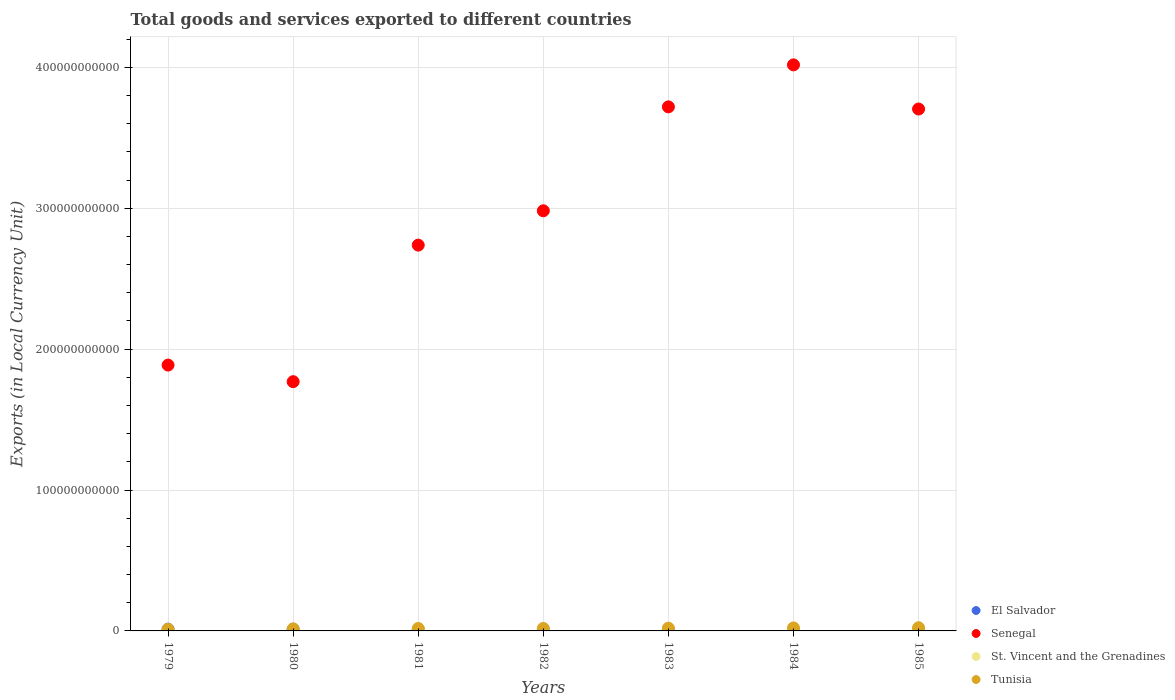How many different coloured dotlines are there?
Make the answer very short. 4. Is the number of dotlines equal to the number of legend labels?
Offer a very short reply. Yes. What is the Amount of goods and services exports in St. Vincent and the Grenadines in 1982?
Offer a very short reply. 1.36e+08. Across all years, what is the maximum Amount of goods and services exports in Tunisia?
Give a very brief answer. 2.25e+09. Across all years, what is the minimum Amount of goods and services exports in St. Vincent and the Grenadines?
Make the answer very short. 7.63e+07. In which year was the Amount of goods and services exports in El Salvador maximum?
Offer a terse response. 1979. In which year was the Amount of goods and services exports in St. Vincent and the Grenadines minimum?
Provide a short and direct response. 1979. What is the total Amount of goods and services exports in Senegal in the graph?
Make the answer very short. 2.08e+12. What is the difference between the Amount of goods and services exports in Senegal in 1982 and that in 1984?
Keep it short and to the point. -1.04e+11. What is the difference between the Amount of goods and services exports in El Salvador in 1983 and the Amount of goods and services exports in Tunisia in 1980?
Make the answer very short. -5.66e+08. What is the average Amount of goods and services exports in El Salvador per year?
Provide a short and direct response. 9.57e+08. In the year 1980, what is the difference between the Amount of goods and services exports in El Salvador and Amount of goods and services exports in St. Vincent and the Grenadines?
Ensure brevity in your answer.  1.13e+09. What is the ratio of the Amount of goods and services exports in St. Vincent and the Grenadines in 1981 to that in 1985?
Keep it short and to the point. 0.52. What is the difference between the highest and the second highest Amount of goods and services exports in El Salvador?
Your answer should be compact. 5.96e+07. What is the difference between the highest and the lowest Amount of goods and services exports in Tunisia?
Offer a terse response. 1.11e+09. In how many years, is the Amount of goods and services exports in Senegal greater than the average Amount of goods and services exports in Senegal taken over all years?
Keep it short and to the point. 4. Is it the case that in every year, the sum of the Amount of goods and services exports in El Salvador and Amount of goods and services exports in St. Vincent and the Grenadines  is greater than the sum of Amount of goods and services exports in Tunisia and Amount of goods and services exports in Senegal?
Provide a short and direct response. Yes. Does the Amount of goods and services exports in El Salvador monotonically increase over the years?
Your answer should be very brief. No. Is the Amount of goods and services exports in El Salvador strictly less than the Amount of goods and services exports in Tunisia over the years?
Give a very brief answer. No. How many years are there in the graph?
Provide a succinct answer. 7. What is the difference between two consecutive major ticks on the Y-axis?
Ensure brevity in your answer.  1.00e+11. Are the values on the major ticks of Y-axis written in scientific E-notation?
Your answer should be compact. No. Does the graph contain any zero values?
Provide a succinct answer. No. Does the graph contain grids?
Your answer should be compact. Yes. Where does the legend appear in the graph?
Provide a short and direct response. Bottom right. How many legend labels are there?
Give a very brief answer. 4. What is the title of the graph?
Offer a terse response. Total goods and services exported to different countries. What is the label or title of the X-axis?
Ensure brevity in your answer.  Years. What is the label or title of the Y-axis?
Your answer should be compact. Exports (in Local Currency Unit). What is the Exports (in Local Currency Unit) of El Salvador in 1979?
Your answer should be compact. 1.28e+09. What is the Exports (in Local Currency Unit) in Senegal in 1979?
Provide a succinct answer. 1.89e+11. What is the Exports (in Local Currency Unit) of St. Vincent and the Grenadines in 1979?
Keep it short and to the point. 7.63e+07. What is the Exports (in Local Currency Unit) in Tunisia in 1979?
Offer a terse response. 1.14e+09. What is the Exports (in Local Currency Unit) of El Salvador in 1980?
Your answer should be compact. 1.22e+09. What is the Exports (in Local Currency Unit) in Senegal in 1980?
Offer a terse response. 1.77e+11. What is the Exports (in Local Currency Unit) of St. Vincent and the Grenadines in 1980?
Keep it short and to the point. 8.95e+07. What is the Exports (in Local Currency Unit) of Tunisia in 1980?
Offer a very short reply. 1.42e+09. What is the Exports (in Local Currency Unit) of El Salvador in 1981?
Your answer should be compact. 9.17e+08. What is the Exports (in Local Currency Unit) in Senegal in 1981?
Give a very brief answer. 2.74e+11. What is the Exports (in Local Currency Unit) of St. Vincent and the Grenadines in 1981?
Provide a succinct answer. 1.16e+08. What is the Exports (in Local Currency Unit) of Tunisia in 1981?
Make the answer very short. 1.72e+09. What is the Exports (in Local Currency Unit) in El Salvador in 1982?
Make the answer very short. 7.74e+08. What is the Exports (in Local Currency Unit) in Senegal in 1982?
Provide a short and direct response. 2.98e+11. What is the Exports (in Local Currency Unit) in St. Vincent and the Grenadines in 1982?
Offer a very short reply. 1.36e+08. What is the Exports (in Local Currency Unit) of Tunisia in 1982?
Make the answer very short. 1.77e+09. What is the Exports (in Local Currency Unit) of El Salvador in 1983?
Make the answer very short. 8.59e+08. What is the Exports (in Local Currency Unit) in Senegal in 1983?
Make the answer very short. 3.72e+11. What is the Exports (in Local Currency Unit) in St. Vincent and the Grenadines in 1983?
Offer a terse response. 1.56e+08. What is the Exports (in Local Currency Unit) of Tunisia in 1983?
Keep it short and to the point. 1.95e+09. What is the Exports (in Local Currency Unit) in El Salvador in 1984?
Your answer should be very brief. 7.97e+08. What is the Exports (in Local Currency Unit) in Senegal in 1984?
Your answer should be very brief. 4.02e+11. What is the Exports (in Local Currency Unit) of St. Vincent and the Grenadines in 1984?
Provide a short and direct response. 1.93e+08. What is the Exports (in Local Currency Unit) of Tunisia in 1984?
Give a very brief answer. 2.11e+09. What is the Exports (in Local Currency Unit) in El Salvador in 1985?
Give a very brief answer. 8.48e+08. What is the Exports (in Local Currency Unit) of Senegal in 1985?
Keep it short and to the point. 3.70e+11. What is the Exports (in Local Currency Unit) in St. Vincent and the Grenadines in 1985?
Keep it short and to the point. 2.22e+08. What is the Exports (in Local Currency Unit) of Tunisia in 1985?
Keep it short and to the point. 2.25e+09. Across all years, what is the maximum Exports (in Local Currency Unit) in El Salvador?
Your response must be concise. 1.28e+09. Across all years, what is the maximum Exports (in Local Currency Unit) in Senegal?
Your answer should be compact. 4.02e+11. Across all years, what is the maximum Exports (in Local Currency Unit) of St. Vincent and the Grenadines?
Your answer should be compact. 2.22e+08. Across all years, what is the maximum Exports (in Local Currency Unit) of Tunisia?
Provide a succinct answer. 2.25e+09. Across all years, what is the minimum Exports (in Local Currency Unit) of El Salvador?
Offer a very short reply. 7.74e+08. Across all years, what is the minimum Exports (in Local Currency Unit) in Senegal?
Provide a short and direct response. 1.77e+11. Across all years, what is the minimum Exports (in Local Currency Unit) in St. Vincent and the Grenadines?
Provide a short and direct response. 7.63e+07. Across all years, what is the minimum Exports (in Local Currency Unit) of Tunisia?
Offer a terse response. 1.14e+09. What is the total Exports (in Local Currency Unit) in El Salvador in the graph?
Ensure brevity in your answer.  6.70e+09. What is the total Exports (in Local Currency Unit) in Senegal in the graph?
Your answer should be very brief. 2.08e+12. What is the total Exports (in Local Currency Unit) in St. Vincent and the Grenadines in the graph?
Your response must be concise. 9.89e+08. What is the total Exports (in Local Currency Unit) in Tunisia in the graph?
Provide a succinct answer. 1.24e+1. What is the difference between the Exports (in Local Currency Unit) in El Salvador in 1979 and that in 1980?
Ensure brevity in your answer.  5.96e+07. What is the difference between the Exports (in Local Currency Unit) in Senegal in 1979 and that in 1980?
Provide a succinct answer. 1.18e+1. What is the difference between the Exports (in Local Currency Unit) of St. Vincent and the Grenadines in 1979 and that in 1980?
Your answer should be very brief. -1.32e+07. What is the difference between the Exports (in Local Currency Unit) in Tunisia in 1979 and that in 1980?
Provide a succinct answer. -2.86e+08. What is the difference between the Exports (in Local Currency Unit) in El Salvador in 1979 and that in 1981?
Ensure brevity in your answer.  3.64e+08. What is the difference between the Exports (in Local Currency Unit) in Senegal in 1979 and that in 1981?
Keep it short and to the point. -8.51e+1. What is the difference between the Exports (in Local Currency Unit) of St. Vincent and the Grenadines in 1979 and that in 1981?
Keep it short and to the point. -3.97e+07. What is the difference between the Exports (in Local Currency Unit) of Tunisia in 1979 and that in 1981?
Keep it short and to the point. -5.83e+08. What is the difference between the Exports (in Local Currency Unit) in El Salvador in 1979 and that in 1982?
Provide a succinct answer. 5.06e+08. What is the difference between the Exports (in Local Currency Unit) of Senegal in 1979 and that in 1982?
Keep it short and to the point. -1.10e+11. What is the difference between the Exports (in Local Currency Unit) in St. Vincent and the Grenadines in 1979 and that in 1982?
Ensure brevity in your answer.  -5.96e+07. What is the difference between the Exports (in Local Currency Unit) in Tunisia in 1979 and that in 1982?
Ensure brevity in your answer.  -6.34e+08. What is the difference between the Exports (in Local Currency Unit) in El Salvador in 1979 and that in 1983?
Your answer should be very brief. 4.22e+08. What is the difference between the Exports (in Local Currency Unit) in Senegal in 1979 and that in 1983?
Your response must be concise. -1.83e+11. What is the difference between the Exports (in Local Currency Unit) of St. Vincent and the Grenadines in 1979 and that in 1983?
Offer a very short reply. -7.94e+07. What is the difference between the Exports (in Local Currency Unit) of Tunisia in 1979 and that in 1983?
Your response must be concise. -8.09e+08. What is the difference between the Exports (in Local Currency Unit) of El Salvador in 1979 and that in 1984?
Your answer should be very brief. 4.84e+08. What is the difference between the Exports (in Local Currency Unit) in Senegal in 1979 and that in 1984?
Give a very brief answer. -2.13e+11. What is the difference between the Exports (in Local Currency Unit) of St. Vincent and the Grenadines in 1979 and that in 1984?
Your answer should be compact. -1.17e+08. What is the difference between the Exports (in Local Currency Unit) in Tunisia in 1979 and that in 1984?
Ensure brevity in your answer.  -9.75e+08. What is the difference between the Exports (in Local Currency Unit) in El Salvador in 1979 and that in 1985?
Your answer should be compact. 4.32e+08. What is the difference between the Exports (in Local Currency Unit) in Senegal in 1979 and that in 1985?
Your answer should be very brief. -1.82e+11. What is the difference between the Exports (in Local Currency Unit) of St. Vincent and the Grenadines in 1979 and that in 1985?
Your answer should be very brief. -1.46e+08. What is the difference between the Exports (in Local Currency Unit) in Tunisia in 1979 and that in 1985?
Offer a terse response. -1.11e+09. What is the difference between the Exports (in Local Currency Unit) in El Salvador in 1980 and that in 1981?
Make the answer very short. 3.04e+08. What is the difference between the Exports (in Local Currency Unit) of Senegal in 1980 and that in 1981?
Offer a very short reply. -9.69e+1. What is the difference between the Exports (in Local Currency Unit) in St. Vincent and the Grenadines in 1980 and that in 1981?
Keep it short and to the point. -2.65e+07. What is the difference between the Exports (in Local Currency Unit) in Tunisia in 1980 and that in 1981?
Give a very brief answer. -2.97e+08. What is the difference between the Exports (in Local Currency Unit) of El Salvador in 1980 and that in 1982?
Keep it short and to the point. 4.47e+08. What is the difference between the Exports (in Local Currency Unit) in Senegal in 1980 and that in 1982?
Offer a very short reply. -1.21e+11. What is the difference between the Exports (in Local Currency Unit) of St. Vincent and the Grenadines in 1980 and that in 1982?
Make the answer very short. -4.65e+07. What is the difference between the Exports (in Local Currency Unit) of Tunisia in 1980 and that in 1982?
Give a very brief answer. -3.49e+08. What is the difference between the Exports (in Local Currency Unit) in El Salvador in 1980 and that in 1983?
Offer a terse response. 3.62e+08. What is the difference between the Exports (in Local Currency Unit) in Senegal in 1980 and that in 1983?
Keep it short and to the point. -1.95e+11. What is the difference between the Exports (in Local Currency Unit) of St. Vincent and the Grenadines in 1980 and that in 1983?
Ensure brevity in your answer.  -6.63e+07. What is the difference between the Exports (in Local Currency Unit) in Tunisia in 1980 and that in 1983?
Make the answer very short. -5.23e+08. What is the difference between the Exports (in Local Currency Unit) in El Salvador in 1980 and that in 1984?
Give a very brief answer. 4.24e+08. What is the difference between the Exports (in Local Currency Unit) of Senegal in 1980 and that in 1984?
Keep it short and to the point. -2.25e+11. What is the difference between the Exports (in Local Currency Unit) of St. Vincent and the Grenadines in 1980 and that in 1984?
Your response must be concise. -1.03e+08. What is the difference between the Exports (in Local Currency Unit) of Tunisia in 1980 and that in 1984?
Make the answer very short. -6.89e+08. What is the difference between the Exports (in Local Currency Unit) in El Salvador in 1980 and that in 1985?
Keep it short and to the point. 3.73e+08. What is the difference between the Exports (in Local Currency Unit) in Senegal in 1980 and that in 1985?
Keep it short and to the point. -1.94e+11. What is the difference between the Exports (in Local Currency Unit) of St. Vincent and the Grenadines in 1980 and that in 1985?
Offer a very short reply. -1.33e+08. What is the difference between the Exports (in Local Currency Unit) in Tunisia in 1980 and that in 1985?
Offer a terse response. -8.28e+08. What is the difference between the Exports (in Local Currency Unit) in El Salvador in 1981 and that in 1982?
Provide a succinct answer. 1.43e+08. What is the difference between the Exports (in Local Currency Unit) in Senegal in 1981 and that in 1982?
Your answer should be compact. -2.44e+1. What is the difference between the Exports (in Local Currency Unit) of St. Vincent and the Grenadines in 1981 and that in 1982?
Provide a short and direct response. -2.00e+07. What is the difference between the Exports (in Local Currency Unit) of Tunisia in 1981 and that in 1982?
Provide a short and direct response. -5.14e+07. What is the difference between the Exports (in Local Currency Unit) of El Salvador in 1981 and that in 1983?
Give a very brief answer. 5.83e+07. What is the difference between the Exports (in Local Currency Unit) in Senegal in 1981 and that in 1983?
Ensure brevity in your answer.  -9.81e+1. What is the difference between the Exports (in Local Currency Unit) in St. Vincent and the Grenadines in 1981 and that in 1983?
Offer a very short reply. -3.98e+07. What is the difference between the Exports (in Local Currency Unit) of Tunisia in 1981 and that in 1983?
Keep it short and to the point. -2.26e+08. What is the difference between the Exports (in Local Currency Unit) in El Salvador in 1981 and that in 1984?
Give a very brief answer. 1.20e+08. What is the difference between the Exports (in Local Currency Unit) in Senegal in 1981 and that in 1984?
Provide a succinct answer. -1.28e+11. What is the difference between the Exports (in Local Currency Unit) in St. Vincent and the Grenadines in 1981 and that in 1984?
Offer a very short reply. -7.70e+07. What is the difference between the Exports (in Local Currency Unit) in Tunisia in 1981 and that in 1984?
Offer a terse response. -3.92e+08. What is the difference between the Exports (in Local Currency Unit) of El Salvador in 1981 and that in 1985?
Offer a very short reply. 6.86e+07. What is the difference between the Exports (in Local Currency Unit) in Senegal in 1981 and that in 1985?
Offer a terse response. -9.66e+1. What is the difference between the Exports (in Local Currency Unit) of St. Vincent and the Grenadines in 1981 and that in 1985?
Offer a terse response. -1.06e+08. What is the difference between the Exports (in Local Currency Unit) in Tunisia in 1981 and that in 1985?
Your answer should be very brief. -5.31e+08. What is the difference between the Exports (in Local Currency Unit) of El Salvador in 1982 and that in 1983?
Ensure brevity in your answer.  -8.44e+07. What is the difference between the Exports (in Local Currency Unit) of Senegal in 1982 and that in 1983?
Provide a short and direct response. -7.38e+1. What is the difference between the Exports (in Local Currency Unit) of St. Vincent and the Grenadines in 1982 and that in 1983?
Your answer should be very brief. -1.98e+07. What is the difference between the Exports (in Local Currency Unit) of Tunisia in 1982 and that in 1983?
Make the answer very short. -1.74e+08. What is the difference between the Exports (in Local Currency Unit) of El Salvador in 1982 and that in 1984?
Make the answer very short. -2.23e+07. What is the difference between the Exports (in Local Currency Unit) of Senegal in 1982 and that in 1984?
Make the answer very short. -1.04e+11. What is the difference between the Exports (in Local Currency Unit) of St. Vincent and the Grenadines in 1982 and that in 1984?
Give a very brief answer. -5.70e+07. What is the difference between the Exports (in Local Currency Unit) in Tunisia in 1982 and that in 1984?
Offer a terse response. -3.40e+08. What is the difference between the Exports (in Local Currency Unit) of El Salvador in 1982 and that in 1985?
Offer a terse response. -7.41e+07. What is the difference between the Exports (in Local Currency Unit) in Senegal in 1982 and that in 1985?
Offer a terse response. -7.22e+1. What is the difference between the Exports (in Local Currency Unit) in St. Vincent and the Grenadines in 1982 and that in 1985?
Your answer should be compact. -8.66e+07. What is the difference between the Exports (in Local Currency Unit) in Tunisia in 1982 and that in 1985?
Provide a short and direct response. -4.80e+08. What is the difference between the Exports (in Local Currency Unit) of El Salvador in 1983 and that in 1984?
Your answer should be very brief. 6.21e+07. What is the difference between the Exports (in Local Currency Unit) of Senegal in 1983 and that in 1984?
Provide a short and direct response. -2.98e+1. What is the difference between the Exports (in Local Currency Unit) of St. Vincent and the Grenadines in 1983 and that in 1984?
Your answer should be compact. -3.72e+07. What is the difference between the Exports (in Local Currency Unit) in Tunisia in 1983 and that in 1984?
Give a very brief answer. -1.66e+08. What is the difference between the Exports (in Local Currency Unit) in El Salvador in 1983 and that in 1985?
Your answer should be very brief. 1.03e+07. What is the difference between the Exports (in Local Currency Unit) in Senegal in 1983 and that in 1985?
Make the answer very short. 1.54e+09. What is the difference between the Exports (in Local Currency Unit) of St. Vincent and the Grenadines in 1983 and that in 1985?
Provide a succinct answer. -6.67e+07. What is the difference between the Exports (in Local Currency Unit) in Tunisia in 1983 and that in 1985?
Provide a succinct answer. -3.05e+08. What is the difference between the Exports (in Local Currency Unit) in El Salvador in 1984 and that in 1985?
Make the answer very short. -5.18e+07. What is the difference between the Exports (in Local Currency Unit) in Senegal in 1984 and that in 1985?
Offer a terse response. 3.13e+1. What is the difference between the Exports (in Local Currency Unit) in St. Vincent and the Grenadines in 1984 and that in 1985?
Your response must be concise. -2.95e+07. What is the difference between the Exports (in Local Currency Unit) of Tunisia in 1984 and that in 1985?
Offer a very short reply. -1.39e+08. What is the difference between the Exports (in Local Currency Unit) of El Salvador in 1979 and the Exports (in Local Currency Unit) of Senegal in 1980?
Provide a succinct answer. -1.76e+11. What is the difference between the Exports (in Local Currency Unit) of El Salvador in 1979 and the Exports (in Local Currency Unit) of St. Vincent and the Grenadines in 1980?
Ensure brevity in your answer.  1.19e+09. What is the difference between the Exports (in Local Currency Unit) in El Salvador in 1979 and the Exports (in Local Currency Unit) in Tunisia in 1980?
Ensure brevity in your answer.  -1.44e+08. What is the difference between the Exports (in Local Currency Unit) in Senegal in 1979 and the Exports (in Local Currency Unit) in St. Vincent and the Grenadines in 1980?
Your answer should be very brief. 1.89e+11. What is the difference between the Exports (in Local Currency Unit) of Senegal in 1979 and the Exports (in Local Currency Unit) of Tunisia in 1980?
Your answer should be very brief. 1.87e+11. What is the difference between the Exports (in Local Currency Unit) in St. Vincent and the Grenadines in 1979 and the Exports (in Local Currency Unit) in Tunisia in 1980?
Your response must be concise. -1.35e+09. What is the difference between the Exports (in Local Currency Unit) in El Salvador in 1979 and the Exports (in Local Currency Unit) in Senegal in 1981?
Your response must be concise. -2.73e+11. What is the difference between the Exports (in Local Currency Unit) in El Salvador in 1979 and the Exports (in Local Currency Unit) in St. Vincent and the Grenadines in 1981?
Keep it short and to the point. 1.16e+09. What is the difference between the Exports (in Local Currency Unit) in El Salvador in 1979 and the Exports (in Local Currency Unit) in Tunisia in 1981?
Give a very brief answer. -4.41e+08. What is the difference between the Exports (in Local Currency Unit) of Senegal in 1979 and the Exports (in Local Currency Unit) of St. Vincent and the Grenadines in 1981?
Give a very brief answer. 1.89e+11. What is the difference between the Exports (in Local Currency Unit) in Senegal in 1979 and the Exports (in Local Currency Unit) in Tunisia in 1981?
Your answer should be compact. 1.87e+11. What is the difference between the Exports (in Local Currency Unit) of St. Vincent and the Grenadines in 1979 and the Exports (in Local Currency Unit) of Tunisia in 1981?
Your answer should be compact. -1.65e+09. What is the difference between the Exports (in Local Currency Unit) in El Salvador in 1979 and the Exports (in Local Currency Unit) in Senegal in 1982?
Your answer should be very brief. -2.97e+11. What is the difference between the Exports (in Local Currency Unit) in El Salvador in 1979 and the Exports (in Local Currency Unit) in St. Vincent and the Grenadines in 1982?
Provide a succinct answer. 1.14e+09. What is the difference between the Exports (in Local Currency Unit) of El Salvador in 1979 and the Exports (in Local Currency Unit) of Tunisia in 1982?
Offer a terse response. -4.93e+08. What is the difference between the Exports (in Local Currency Unit) of Senegal in 1979 and the Exports (in Local Currency Unit) of St. Vincent and the Grenadines in 1982?
Your answer should be very brief. 1.89e+11. What is the difference between the Exports (in Local Currency Unit) of Senegal in 1979 and the Exports (in Local Currency Unit) of Tunisia in 1982?
Your response must be concise. 1.87e+11. What is the difference between the Exports (in Local Currency Unit) of St. Vincent and the Grenadines in 1979 and the Exports (in Local Currency Unit) of Tunisia in 1982?
Provide a short and direct response. -1.70e+09. What is the difference between the Exports (in Local Currency Unit) of El Salvador in 1979 and the Exports (in Local Currency Unit) of Senegal in 1983?
Ensure brevity in your answer.  -3.71e+11. What is the difference between the Exports (in Local Currency Unit) of El Salvador in 1979 and the Exports (in Local Currency Unit) of St. Vincent and the Grenadines in 1983?
Give a very brief answer. 1.12e+09. What is the difference between the Exports (in Local Currency Unit) in El Salvador in 1979 and the Exports (in Local Currency Unit) in Tunisia in 1983?
Your answer should be very brief. -6.67e+08. What is the difference between the Exports (in Local Currency Unit) of Senegal in 1979 and the Exports (in Local Currency Unit) of St. Vincent and the Grenadines in 1983?
Provide a succinct answer. 1.89e+11. What is the difference between the Exports (in Local Currency Unit) in Senegal in 1979 and the Exports (in Local Currency Unit) in Tunisia in 1983?
Your answer should be very brief. 1.87e+11. What is the difference between the Exports (in Local Currency Unit) in St. Vincent and the Grenadines in 1979 and the Exports (in Local Currency Unit) in Tunisia in 1983?
Your answer should be compact. -1.87e+09. What is the difference between the Exports (in Local Currency Unit) of El Salvador in 1979 and the Exports (in Local Currency Unit) of Senegal in 1984?
Offer a terse response. -4.00e+11. What is the difference between the Exports (in Local Currency Unit) of El Salvador in 1979 and the Exports (in Local Currency Unit) of St. Vincent and the Grenadines in 1984?
Give a very brief answer. 1.09e+09. What is the difference between the Exports (in Local Currency Unit) in El Salvador in 1979 and the Exports (in Local Currency Unit) in Tunisia in 1984?
Provide a short and direct response. -8.33e+08. What is the difference between the Exports (in Local Currency Unit) in Senegal in 1979 and the Exports (in Local Currency Unit) in St. Vincent and the Grenadines in 1984?
Give a very brief answer. 1.88e+11. What is the difference between the Exports (in Local Currency Unit) of Senegal in 1979 and the Exports (in Local Currency Unit) of Tunisia in 1984?
Provide a succinct answer. 1.87e+11. What is the difference between the Exports (in Local Currency Unit) in St. Vincent and the Grenadines in 1979 and the Exports (in Local Currency Unit) in Tunisia in 1984?
Your answer should be compact. -2.04e+09. What is the difference between the Exports (in Local Currency Unit) of El Salvador in 1979 and the Exports (in Local Currency Unit) of Senegal in 1985?
Keep it short and to the point. -3.69e+11. What is the difference between the Exports (in Local Currency Unit) of El Salvador in 1979 and the Exports (in Local Currency Unit) of St. Vincent and the Grenadines in 1985?
Offer a terse response. 1.06e+09. What is the difference between the Exports (in Local Currency Unit) of El Salvador in 1979 and the Exports (in Local Currency Unit) of Tunisia in 1985?
Keep it short and to the point. -9.73e+08. What is the difference between the Exports (in Local Currency Unit) in Senegal in 1979 and the Exports (in Local Currency Unit) in St. Vincent and the Grenadines in 1985?
Offer a very short reply. 1.88e+11. What is the difference between the Exports (in Local Currency Unit) of Senegal in 1979 and the Exports (in Local Currency Unit) of Tunisia in 1985?
Provide a succinct answer. 1.86e+11. What is the difference between the Exports (in Local Currency Unit) in St. Vincent and the Grenadines in 1979 and the Exports (in Local Currency Unit) in Tunisia in 1985?
Your response must be concise. -2.18e+09. What is the difference between the Exports (in Local Currency Unit) of El Salvador in 1980 and the Exports (in Local Currency Unit) of Senegal in 1981?
Give a very brief answer. -2.73e+11. What is the difference between the Exports (in Local Currency Unit) of El Salvador in 1980 and the Exports (in Local Currency Unit) of St. Vincent and the Grenadines in 1981?
Provide a succinct answer. 1.10e+09. What is the difference between the Exports (in Local Currency Unit) in El Salvador in 1980 and the Exports (in Local Currency Unit) in Tunisia in 1981?
Your answer should be compact. -5.01e+08. What is the difference between the Exports (in Local Currency Unit) in Senegal in 1980 and the Exports (in Local Currency Unit) in St. Vincent and the Grenadines in 1981?
Provide a succinct answer. 1.77e+11. What is the difference between the Exports (in Local Currency Unit) in Senegal in 1980 and the Exports (in Local Currency Unit) in Tunisia in 1981?
Offer a terse response. 1.75e+11. What is the difference between the Exports (in Local Currency Unit) of St. Vincent and the Grenadines in 1980 and the Exports (in Local Currency Unit) of Tunisia in 1981?
Make the answer very short. -1.63e+09. What is the difference between the Exports (in Local Currency Unit) of El Salvador in 1980 and the Exports (in Local Currency Unit) of Senegal in 1982?
Your answer should be very brief. -2.97e+11. What is the difference between the Exports (in Local Currency Unit) in El Salvador in 1980 and the Exports (in Local Currency Unit) in St. Vincent and the Grenadines in 1982?
Your answer should be compact. 1.08e+09. What is the difference between the Exports (in Local Currency Unit) in El Salvador in 1980 and the Exports (in Local Currency Unit) in Tunisia in 1982?
Provide a short and direct response. -5.52e+08. What is the difference between the Exports (in Local Currency Unit) in Senegal in 1980 and the Exports (in Local Currency Unit) in St. Vincent and the Grenadines in 1982?
Your answer should be very brief. 1.77e+11. What is the difference between the Exports (in Local Currency Unit) in Senegal in 1980 and the Exports (in Local Currency Unit) in Tunisia in 1982?
Offer a very short reply. 1.75e+11. What is the difference between the Exports (in Local Currency Unit) of St. Vincent and the Grenadines in 1980 and the Exports (in Local Currency Unit) of Tunisia in 1982?
Ensure brevity in your answer.  -1.68e+09. What is the difference between the Exports (in Local Currency Unit) of El Salvador in 1980 and the Exports (in Local Currency Unit) of Senegal in 1983?
Keep it short and to the point. -3.71e+11. What is the difference between the Exports (in Local Currency Unit) of El Salvador in 1980 and the Exports (in Local Currency Unit) of St. Vincent and the Grenadines in 1983?
Offer a terse response. 1.07e+09. What is the difference between the Exports (in Local Currency Unit) in El Salvador in 1980 and the Exports (in Local Currency Unit) in Tunisia in 1983?
Your answer should be compact. -7.27e+08. What is the difference between the Exports (in Local Currency Unit) in Senegal in 1980 and the Exports (in Local Currency Unit) in St. Vincent and the Grenadines in 1983?
Give a very brief answer. 1.77e+11. What is the difference between the Exports (in Local Currency Unit) of Senegal in 1980 and the Exports (in Local Currency Unit) of Tunisia in 1983?
Ensure brevity in your answer.  1.75e+11. What is the difference between the Exports (in Local Currency Unit) of St. Vincent and the Grenadines in 1980 and the Exports (in Local Currency Unit) of Tunisia in 1983?
Offer a terse response. -1.86e+09. What is the difference between the Exports (in Local Currency Unit) in El Salvador in 1980 and the Exports (in Local Currency Unit) in Senegal in 1984?
Your response must be concise. -4.01e+11. What is the difference between the Exports (in Local Currency Unit) of El Salvador in 1980 and the Exports (in Local Currency Unit) of St. Vincent and the Grenadines in 1984?
Make the answer very short. 1.03e+09. What is the difference between the Exports (in Local Currency Unit) of El Salvador in 1980 and the Exports (in Local Currency Unit) of Tunisia in 1984?
Offer a very short reply. -8.93e+08. What is the difference between the Exports (in Local Currency Unit) of Senegal in 1980 and the Exports (in Local Currency Unit) of St. Vincent and the Grenadines in 1984?
Make the answer very short. 1.77e+11. What is the difference between the Exports (in Local Currency Unit) of Senegal in 1980 and the Exports (in Local Currency Unit) of Tunisia in 1984?
Your answer should be compact. 1.75e+11. What is the difference between the Exports (in Local Currency Unit) of St. Vincent and the Grenadines in 1980 and the Exports (in Local Currency Unit) of Tunisia in 1984?
Offer a very short reply. -2.02e+09. What is the difference between the Exports (in Local Currency Unit) in El Salvador in 1980 and the Exports (in Local Currency Unit) in Senegal in 1985?
Provide a short and direct response. -3.69e+11. What is the difference between the Exports (in Local Currency Unit) in El Salvador in 1980 and the Exports (in Local Currency Unit) in St. Vincent and the Grenadines in 1985?
Offer a terse response. 9.98e+08. What is the difference between the Exports (in Local Currency Unit) of El Salvador in 1980 and the Exports (in Local Currency Unit) of Tunisia in 1985?
Make the answer very short. -1.03e+09. What is the difference between the Exports (in Local Currency Unit) of Senegal in 1980 and the Exports (in Local Currency Unit) of St. Vincent and the Grenadines in 1985?
Offer a terse response. 1.77e+11. What is the difference between the Exports (in Local Currency Unit) of Senegal in 1980 and the Exports (in Local Currency Unit) of Tunisia in 1985?
Give a very brief answer. 1.75e+11. What is the difference between the Exports (in Local Currency Unit) of St. Vincent and the Grenadines in 1980 and the Exports (in Local Currency Unit) of Tunisia in 1985?
Offer a terse response. -2.16e+09. What is the difference between the Exports (in Local Currency Unit) of El Salvador in 1981 and the Exports (in Local Currency Unit) of Senegal in 1982?
Make the answer very short. -2.97e+11. What is the difference between the Exports (in Local Currency Unit) of El Salvador in 1981 and the Exports (in Local Currency Unit) of St. Vincent and the Grenadines in 1982?
Your response must be concise. 7.81e+08. What is the difference between the Exports (in Local Currency Unit) of El Salvador in 1981 and the Exports (in Local Currency Unit) of Tunisia in 1982?
Keep it short and to the point. -8.56e+08. What is the difference between the Exports (in Local Currency Unit) in Senegal in 1981 and the Exports (in Local Currency Unit) in St. Vincent and the Grenadines in 1982?
Make the answer very short. 2.74e+11. What is the difference between the Exports (in Local Currency Unit) in Senegal in 1981 and the Exports (in Local Currency Unit) in Tunisia in 1982?
Offer a very short reply. 2.72e+11. What is the difference between the Exports (in Local Currency Unit) in St. Vincent and the Grenadines in 1981 and the Exports (in Local Currency Unit) in Tunisia in 1982?
Your answer should be very brief. -1.66e+09. What is the difference between the Exports (in Local Currency Unit) in El Salvador in 1981 and the Exports (in Local Currency Unit) in Senegal in 1983?
Your answer should be very brief. -3.71e+11. What is the difference between the Exports (in Local Currency Unit) of El Salvador in 1981 and the Exports (in Local Currency Unit) of St. Vincent and the Grenadines in 1983?
Your response must be concise. 7.61e+08. What is the difference between the Exports (in Local Currency Unit) in El Salvador in 1981 and the Exports (in Local Currency Unit) in Tunisia in 1983?
Ensure brevity in your answer.  -1.03e+09. What is the difference between the Exports (in Local Currency Unit) of Senegal in 1981 and the Exports (in Local Currency Unit) of St. Vincent and the Grenadines in 1983?
Your answer should be compact. 2.74e+11. What is the difference between the Exports (in Local Currency Unit) in Senegal in 1981 and the Exports (in Local Currency Unit) in Tunisia in 1983?
Provide a short and direct response. 2.72e+11. What is the difference between the Exports (in Local Currency Unit) in St. Vincent and the Grenadines in 1981 and the Exports (in Local Currency Unit) in Tunisia in 1983?
Your answer should be very brief. -1.83e+09. What is the difference between the Exports (in Local Currency Unit) in El Salvador in 1981 and the Exports (in Local Currency Unit) in Senegal in 1984?
Provide a short and direct response. -4.01e+11. What is the difference between the Exports (in Local Currency Unit) in El Salvador in 1981 and the Exports (in Local Currency Unit) in St. Vincent and the Grenadines in 1984?
Ensure brevity in your answer.  7.24e+08. What is the difference between the Exports (in Local Currency Unit) of El Salvador in 1981 and the Exports (in Local Currency Unit) of Tunisia in 1984?
Offer a very short reply. -1.20e+09. What is the difference between the Exports (in Local Currency Unit) in Senegal in 1981 and the Exports (in Local Currency Unit) in St. Vincent and the Grenadines in 1984?
Your answer should be compact. 2.74e+11. What is the difference between the Exports (in Local Currency Unit) of Senegal in 1981 and the Exports (in Local Currency Unit) of Tunisia in 1984?
Your response must be concise. 2.72e+11. What is the difference between the Exports (in Local Currency Unit) in St. Vincent and the Grenadines in 1981 and the Exports (in Local Currency Unit) in Tunisia in 1984?
Your answer should be compact. -2.00e+09. What is the difference between the Exports (in Local Currency Unit) in El Salvador in 1981 and the Exports (in Local Currency Unit) in Senegal in 1985?
Give a very brief answer. -3.69e+11. What is the difference between the Exports (in Local Currency Unit) of El Salvador in 1981 and the Exports (in Local Currency Unit) of St. Vincent and the Grenadines in 1985?
Your answer should be very brief. 6.95e+08. What is the difference between the Exports (in Local Currency Unit) in El Salvador in 1981 and the Exports (in Local Currency Unit) in Tunisia in 1985?
Make the answer very short. -1.34e+09. What is the difference between the Exports (in Local Currency Unit) of Senegal in 1981 and the Exports (in Local Currency Unit) of St. Vincent and the Grenadines in 1985?
Make the answer very short. 2.74e+11. What is the difference between the Exports (in Local Currency Unit) in Senegal in 1981 and the Exports (in Local Currency Unit) in Tunisia in 1985?
Provide a short and direct response. 2.72e+11. What is the difference between the Exports (in Local Currency Unit) of St. Vincent and the Grenadines in 1981 and the Exports (in Local Currency Unit) of Tunisia in 1985?
Offer a very short reply. -2.14e+09. What is the difference between the Exports (in Local Currency Unit) of El Salvador in 1982 and the Exports (in Local Currency Unit) of Senegal in 1983?
Your answer should be compact. -3.71e+11. What is the difference between the Exports (in Local Currency Unit) of El Salvador in 1982 and the Exports (in Local Currency Unit) of St. Vincent and the Grenadines in 1983?
Ensure brevity in your answer.  6.19e+08. What is the difference between the Exports (in Local Currency Unit) of El Salvador in 1982 and the Exports (in Local Currency Unit) of Tunisia in 1983?
Make the answer very short. -1.17e+09. What is the difference between the Exports (in Local Currency Unit) of Senegal in 1982 and the Exports (in Local Currency Unit) of St. Vincent and the Grenadines in 1983?
Your answer should be compact. 2.98e+11. What is the difference between the Exports (in Local Currency Unit) in Senegal in 1982 and the Exports (in Local Currency Unit) in Tunisia in 1983?
Give a very brief answer. 2.96e+11. What is the difference between the Exports (in Local Currency Unit) of St. Vincent and the Grenadines in 1982 and the Exports (in Local Currency Unit) of Tunisia in 1983?
Your response must be concise. -1.81e+09. What is the difference between the Exports (in Local Currency Unit) of El Salvador in 1982 and the Exports (in Local Currency Unit) of Senegal in 1984?
Your answer should be compact. -4.01e+11. What is the difference between the Exports (in Local Currency Unit) in El Salvador in 1982 and the Exports (in Local Currency Unit) in St. Vincent and the Grenadines in 1984?
Keep it short and to the point. 5.81e+08. What is the difference between the Exports (in Local Currency Unit) of El Salvador in 1982 and the Exports (in Local Currency Unit) of Tunisia in 1984?
Provide a succinct answer. -1.34e+09. What is the difference between the Exports (in Local Currency Unit) in Senegal in 1982 and the Exports (in Local Currency Unit) in St. Vincent and the Grenadines in 1984?
Make the answer very short. 2.98e+11. What is the difference between the Exports (in Local Currency Unit) of Senegal in 1982 and the Exports (in Local Currency Unit) of Tunisia in 1984?
Offer a very short reply. 2.96e+11. What is the difference between the Exports (in Local Currency Unit) of St. Vincent and the Grenadines in 1982 and the Exports (in Local Currency Unit) of Tunisia in 1984?
Provide a short and direct response. -1.98e+09. What is the difference between the Exports (in Local Currency Unit) in El Salvador in 1982 and the Exports (in Local Currency Unit) in Senegal in 1985?
Your response must be concise. -3.70e+11. What is the difference between the Exports (in Local Currency Unit) in El Salvador in 1982 and the Exports (in Local Currency Unit) in St. Vincent and the Grenadines in 1985?
Your response must be concise. 5.52e+08. What is the difference between the Exports (in Local Currency Unit) of El Salvador in 1982 and the Exports (in Local Currency Unit) of Tunisia in 1985?
Your answer should be compact. -1.48e+09. What is the difference between the Exports (in Local Currency Unit) in Senegal in 1982 and the Exports (in Local Currency Unit) in St. Vincent and the Grenadines in 1985?
Ensure brevity in your answer.  2.98e+11. What is the difference between the Exports (in Local Currency Unit) in Senegal in 1982 and the Exports (in Local Currency Unit) in Tunisia in 1985?
Make the answer very short. 2.96e+11. What is the difference between the Exports (in Local Currency Unit) of St. Vincent and the Grenadines in 1982 and the Exports (in Local Currency Unit) of Tunisia in 1985?
Make the answer very short. -2.12e+09. What is the difference between the Exports (in Local Currency Unit) of El Salvador in 1983 and the Exports (in Local Currency Unit) of Senegal in 1984?
Your answer should be compact. -4.01e+11. What is the difference between the Exports (in Local Currency Unit) in El Salvador in 1983 and the Exports (in Local Currency Unit) in St. Vincent and the Grenadines in 1984?
Provide a short and direct response. 6.66e+08. What is the difference between the Exports (in Local Currency Unit) of El Salvador in 1983 and the Exports (in Local Currency Unit) of Tunisia in 1984?
Your answer should be compact. -1.26e+09. What is the difference between the Exports (in Local Currency Unit) of Senegal in 1983 and the Exports (in Local Currency Unit) of St. Vincent and the Grenadines in 1984?
Make the answer very short. 3.72e+11. What is the difference between the Exports (in Local Currency Unit) of Senegal in 1983 and the Exports (in Local Currency Unit) of Tunisia in 1984?
Provide a succinct answer. 3.70e+11. What is the difference between the Exports (in Local Currency Unit) of St. Vincent and the Grenadines in 1983 and the Exports (in Local Currency Unit) of Tunisia in 1984?
Provide a succinct answer. -1.96e+09. What is the difference between the Exports (in Local Currency Unit) of El Salvador in 1983 and the Exports (in Local Currency Unit) of Senegal in 1985?
Ensure brevity in your answer.  -3.70e+11. What is the difference between the Exports (in Local Currency Unit) of El Salvador in 1983 and the Exports (in Local Currency Unit) of St. Vincent and the Grenadines in 1985?
Offer a very short reply. 6.36e+08. What is the difference between the Exports (in Local Currency Unit) in El Salvador in 1983 and the Exports (in Local Currency Unit) in Tunisia in 1985?
Provide a short and direct response. -1.39e+09. What is the difference between the Exports (in Local Currency Unit) of Senegal in 1983 and the Exports (in Local Currency Unit) of St. Vincent and the Grenadines in 1985?
Offer a terse response. 3.72e+11. What is the difference between the Exports (in Local Currency Unit) of Senegal in 1983 and the Exports (in Local Currency Unit) of Tunisia in 1985?
Provide a succinct answer. 3.70e+11. What is the difference between the Exports (in Local Currency Unit) in St. Vincent and the Grenadines in 1983 and the Exports (in Local Currency Unit) in Tunisia in 1985?
Offer a terse response. -2.10e+09. What is the difference between the Exports (in Local Currency Unit) of El Salvador in 1984 and the Exports (in Local Currency Unit) of Senegal in 1985?
Provide a short and direct response. -3.70e+11. What is the difference between the Exports (in Local Currency Unit) of El Salvador in 1984 and the Exports (in Local Currency Unit) of St. Vincent and the Grenadines in 1985?
Your answer should be very brief. 5.74e+08. What is the difference between the Exports (in Local Currency Unit) of El Salvador in 1984 and the Exports (in Local Currency Unit) of Tunisia in 1985?
Your response must be concise. -1.46e+09. What is the difference between the Exports (in Local Currency Unit) of Senegal in 1984 and the Exports (in Local Currency Unit) of St. Vincent and the Grenadines in 1985?
Your response must be concise. 4.02e+11. What is the difference between the Exports (in Local Currency Unit) of Senegal in 1984 and the Exports (in Local Currency Unit) of Tunisia in 1985?
Make the answer very short. 3.99e+11. What is the difference between the Exports (in Local Currency Unit) in St. Vincent and the Grenadines in 1984 and the Exports (in Local Currency Unit) in Tunisia in 1985?
Keep it short and to the point. -2.06e+09. What is the average Exports (in Local Currency Unit) in El Salvador per year?
Provide a succinct answer. 9.57e+08. What is the average Exports (in Local Currency Unit) of Senegal per year?
Offer a terse response. 2.97e+11. What is the average Exports (in Local Currency Unit) of St. Vincent and the Grenadines per year?
Provide a short and direct response. 1.41e+08. What is the average Exports (in Local Currency Unit) of Tunisia per year?
Offer a terse response. 1.77e+09. In the year 1979, what is the difference between the Exports (in Local Currency Unit) in El Salvador and Exports (in Local Currency Unit) in Senegal?
Your answer should be very brief. -1.87e+11. In the year 1979, what is the difference between the Exports (in Local Currency Unit) in El Salvador and Exports (in Local Currency Unit) in St. Vincent and the Grenadines?
Offer a very short reply. 1.20e+09. In the year 1979, what is the difference between the Exports (in Local Currency Unit) of El Salvador and Exports (in Local Currency Unit) of Tunisia?
Your answer should be compact. 1.42e+08. In the year 1979, what is the difference between the Exports (in Local Currency Unit) in Senegal and Exports (in Local Currency Unit) in St. Vincent and the Grenadines?
Your answer should be compact. 1.89e+11. In the year 1979, what is the difference between the Exports (in Local Currency Unit) in Senegal and Exports (in Local Currency Unit) in Tunisia?
Provide a succinct answer. 1.88e+11. In the year 1979, what is the difference between the Exports (in Local Currency Unit) of St. Vincent and the Grenadines and Exports (in Local Currency Unit) of Tunisia?
Offer a very short reply. -1.06e+09. In the year 1980, what is the difference between the Exports (in Local Currency Unit) in El Salvador and Exports (in Local Currency Unit) in Senegal?
Offer a very short reply. -1.76e+11. In the year 1980, what is the difference between the Exports (in Local Currency Unit) of El Salvador and Exports (in Local Currency Unit) of St. Vincent and the Grenadines?
Provide a short and direct response. 1.13e+09. In the year 1980, what is the difference between the Exports (in Local Currency Unit) of El Salvador and Exports (in Local Currency Unit) of Tunisia?
Your answer should be compact. -2.04e+08. In the year 1980, what is the difference between the Exports (in Local Currency Unit) of Senegal and Exports (in Local Currency Unit) of St. Vincent and the Grenadines?
Your response must be concise. 1.77e+11. In the year 1980, what is the difference between the Exports (in Local Currency Unit) of Senegal and Exports (in Local Currency Unit) of Tunisia?
Give a very brief answer. 1.75e+11. In the year 1980, what is the difference between the Exports (in Local Currency Unit) in St. Vincent and the Grenadines and Exports (in Local Currency Unit) in Tunisia?
Your response must be concise. -1.34e+09. In the year 1981, what is the difference between the Exports (in Local Currency Unit) of El Salvador and Exports (in Local Currency Unit) of Senegal?
Your answer should be very brief. -2.73e+11. In the year 1981, what is the difference between the Exports (in Local Currency Unit) of El Salvador and Exports (in Local Currency Unit) of St. Vincent and the Grenadines?
Provide a short and direct response. 8.01e+08. In the year 1981, what is the difference between the Exports (in Local Currency Unit) of El Salvador and Exports (in Local Currency Unit) of Tunisia?
Keep it short and to the point. -8.05e+08. In the year 1981, what is the difference between the Exports (in Local Currency Unit) in Senegal and Exports (in Local Currency Unit) in St. Vincent and the Grenadines?
Offer a terse response. 2.74e+11. In the year 1981, what is the difference between the Exports (in Local Currency Unit) in Senegal and Exports (in Local Currency Unit) in Tunisia?
Your answer should be compact. 2.72e+11. In the year 1981, what is the difference between the Exports (in Local Currency Unit) in St. Vincent and the Grenadines and Exports (in Local Currency Unit) in Tunisia?
Provide a succinct answer. -1.61e+09. In the year 1982, what is the difference between the Exports (in Local Currency Unit) in El Salvador and Exports (in Local Currency Unit) in Senegal?
Ensure brevity in your answer.  -2.97e+11. In the year 1982, what is the difference between the Exports (in Local Currency Unit) in El Salvador and Exports (in Local Currency Unit) in St. Vincent and the Grenadines?
Ensure brevity in your answer.  6.38e+08. In the year 1982, what is the difference between the Exports (in Local Currency Unit) of El Salvador and Exports (in Local Currency Unit) of Tunisia?
Make the answer very short. -9.99e+08. In the year 1982, what is the difference between the Exports (in Local Currency Unit) in Senegal and Exports (in Local Currency Unit) in St. Vincent and the Grenadines?
Provide a short and direct response. 2.98e+11. In the year 1982, what is the difference between the Exports (in Local Currency Unit) in Senegal and Exports (in Local Currency Unit) in Tunisia?
Your answer should be compact. 2.96e+11. In the year 1982, what is the difference between the Exports (in Local Currency Unit) of St. Vincent and the Grenadines and Exports (in Local Currency Unit) of Tunisia?
Your answer should be compact. -1.64e+09. In the year 1983, what is the difference between the Exports (in Local Currency Unit) of El Salvador and Exports (in Local Currency Unit) of Senegal?
Keep it short and to the point. -3.71e+11. In the year 1983, what is the difference between the Exports (in Local Currency Unit) of El Salvador and Exports (in Local Currency Unit) of St. Vincent and the Grenadines?
Your answer should be compact. 7.03e+08. In the year 1983, what is the difference between the Exports (in Local Currency Unit) in El Salvador and Exports (in Local Currency Unit) in Tunisia?
Provide a short and direct response. -1.09e+09. In the year 1983, what is the difference between the Exports (in Local Currency Unit) of Senegal and Exports (in Local Currency Unit) of St. Vincent and the Grenadines?
Your answer should be compact. 3.72e+11. In the year 1983, what is the difference between the Exports (in Local Currency Unit) of Senegal and Exports (in Local Currency Unit) of Tunisia?
Make the answer very short. 3.70e+11. In the year 1983, what is the difference between the Exports (in Local Currency Unit) of St. Vincent and the Grenadines and Exports (in Local Currency Unit) of Tunisia?
Your response must be concise. -1.79e+09. In the year 1984, what is the difference between the Exports (in Local Currency Unit) in El Salvador and Exports (in Local Currency Unit) in Senegal?
Give a very brief answer. -4.01e+11. In the year 1984, what is the difference between the Exports (in Local Currency Unit) in El Salvador and Exports (in Local Currency Unit) in St. Vincent and the Grenadines?
Offer a terse response. 6.04e+08. In the year 1984, what is the difference between the Exports (in Local Currency Unit) in El Salvador and Exports (in Local Currency Unit) in Tunisia?
Your answer should be compact. -1.32e+09. In the year 1984, what is the difference between the Exports (in Local Currency Unit) in Senegal and Exports (in Local Currency Unit) in St. Vincent and the Grenadines?
Provide a succinct answer. 4.02e+11. In the year 1984, what is the difference between the Exports (in Local Currency Unit) in Senegal and Exports (in Local Currency Unit) in Tunisia?
Your answer should be compact. 4.00e+11. In the year 1984, what is the difference between the Exports (in Local Currency Unit) in St. Vincent and the Grenadines and Exports (in Local Currency Unit) in Tunisia?
Provide a short and direct response. -1.92e+09. In the year 1985, what is the difference between the Exports (in Local Currency Unit) in El Salvador and Exports (in Local Currency Unit) in Senegal?
Your answer should be compact. -3.70e+11. In the year 1985, what is the difference between the Exports (in Local Currency Unit) in El Salvador and Exports (in Local Currency Unit) in St. Vincent and the Grenadines?
Keep it short and to the point. 6.26e+08. In the year 1985, what is the difference between the Exports (in Local Currency Unit) of El Salvador and Exports (in Local Currency Unit) of Tunisia?
Give a very brief answer. -1.40e+09. In the year 1985, what is the difference between the Exports (in Local Currency Unit) of Senegal and Exports (in Local Currency Unit) of St. Vincent and the Grenadines?
Your answer should be very brief. 3.70e+11. In the year 1985, what is the difference between the Exports (in Local Currency Unit) of Senegal and Exports (in Local Currency Unit) of Tunisia?
Provide a succinct answer. 3.68e+11. In the year 1985, what is the difference between the Exports (in Local Currency Unit) in St. Vincent and the Grenadines and Exports (in Local Currency Unit) in Tunisia?
Provide a succinct answer. -2.03e+09. What is the ratio of the Exports (in Local Currency Unit) of El Salvador in 1979 to that in 1980?
Provide a short and direct response. 1.05. What is the ratio of the Exports (in Local Currency Unit) of Senegal in 1979 to that in 1980?
Keep it short and to the point. 1.07. What is the ratio of the Exports (in Local Currency Unit) of St. Vincent and the Grenadines in 1979 to that in 1980?
Your response must be concise. 0.85. What is the ratio of the Exports (in Local Currency Unit) of Tunisia in 1979 to that in 1980?
Your answer should be very brief. 0.8. What is the ratio of the Exports (in Local Currency Unit) of El Salvador in 1979 to that in 1981?
Ensure brevity in your answer.  1.4. What is the ratio of the Exports (in Local Currency Unit) of Senegal in 1979 to that in 1981?
Provide a succinct answer. 0.69. What is the ratio of the Exports (in Local Currency Unit) in St. Vincent and the Grenadines in 1979 to that in 1981?
Ensure brevity in your answer.  0.66. What is the ratio of the Exports (in Local Currency Unit) in Tunisia in 1979 to that in 1981?
Ensure brevity in your answer.  0.66. What is the ratio of the Exports (in Local Currency Unit) in El Salvador in 1979 to that in 1982?
Keep it short and to the point. 1.65. What is the ratio of the Exports (in Local Currency Unit) of Senegal in 1979 to that in 1982?
Ensure brevity in your answer.  0.63. What is the ratio of the Exports (in Local Currency Unit) in St. Vincent and the Grenadines in 1979 to that in 1982?
Keep it short and to the point. 0.56. What is the ratio of the Exports (in Local Currency Unit) in Tunisia in 1979 to that in 1982?
Ensure brevity in your answer.  0.64. What is the ratio of the Exports (in Local Currency Unit) in El Salvador in 1979 to that in 1983?
Offer a terse response. 1.49. What is the ratio of the Exports (in Local Currency Unit) in Senegal in 1979 to that in 1983?
Give a very brief answer. 0.51. What is the ratio of the Exports (in Local Currency Unit) in St. Vincent and the Grenadines in 1979 to that in 1983?
Make the answer very short. 0.49. What is the ratio of the Exports (in Local Currency Unit) in Tunisia in 1979 to that in 1983?
Make the answer very short. 0.58. What is the ratio of the Exports (in Local Currency Unit) in El Salvador in 1979 to that in 1984?
Give a very brief answer. 1.61. What is the ratio of the Exports (in Local Currency Unit) of Senegal in 1979 to that in 1984?
Offer a very short reply. 0.47. What is the ratio of the Exports (in Local Currency Unit) in St. Vincent and the Grenadines in 1979 to that in 1984?
Provide a short and direct response. 0.4. What is the ratio of the Exports (in Local Currency Unit) in Tunisia in 1979 to that in 1984?
Offer a terse response. 0.54. What is the ratio of the Exports (in Local Currency Unit) of El Salvador in 1979 to that in 1985?
Ensure brevity in your answer.  1.51. What is the ratio of the Exports (in Local Currency Unit) of Senegal in 1979 to that in 1985?
Your answer should be compact. 0.51. What is the ratio of the Exports (in Local Currency Unit) of St. Vincent and the Grenadines in 1979 to that in 1985?
Offer a very short reply. 0.34. What is the ratio of the Exports (in Local Currency Unit) of Tunisia in 1979 to that in 1985?
Your answer should be very brief. 0.51. What is the ratio of the Exports (in Local Currency Unit) in El Salvador in 1980 to that in 1981?
Keep it short and to the point. 1.33. What is the ratio of the Exports (in Local Currency Unit) in Senegal in 1980 to that in 1981?
Make the answer very short. 0.65. What is the ratio of the Exports (in Local Currency Unit) of St. Vincent and the Grenadines in 1980 to that in 1981?
Your response must be concise. 0.77. What is the ratio of the Exports (in Local Currency Unit) of Tunisia in 1980 to that in 1981?
Provide a short and direct response. 0.83. What is the ratio of the Exports (in Local Currency Unit) of El Salvador in 1980 to that in 1982?
Provide a succinct answer. 1.58. What is the ratio of the Exports (in Local Currency Unit) in Senegal in 1980 to that in 1982?
Give a very brief answer. 0.59. What is the ratio of the Exports (in Local Currency Unit) in St. Vincent and the Grenadines in 1980 to that in 1982?
Provide a short and direct response. 0.66. What is the ratio of the Exports (in Local Currency Unit) of Tunisia in 1980 to that in 1982?
Your answer should be very brief. 0.8. What is the ratio of the Exports (in Local Currency Unit) in El Salvador in 1980 to that in 1983?
Offer a very short reply. 1.42. What is the ratio of the Exports (in Local Currency Unit) in Senegal in 1980 to that in 1983?
Your answer should be very brief. 0.48. What is the ratio of the Exports (in Local Currency Unit) in St. Vincent and the Grenadines in 1980 to that in 1983?
Offer a terse response. 0.57. What is the ratio of the Exports (in Local Currency Unit) of Tunisia in 1980 to that in 1983?
Your response must be concise. 0.73. What is the ratio of the Exports (in Local Currency Unit) of El Salvador in 1980 to that in 1984?
Give a very brief answer. 1.53. What is the ratio of the Exports (in Local Currency Unit) in Senegal in 1980 to that in 1984?
Your answer should be very brief. 0.44. What is the ratio of the Exports (in Local Currency Unit) in St. Vincent and the Grenadines in 1980 to that in 1984?
Ensure brevity in your answer.  0.46. What is the ratio of the Exports (in Local Currency Unit) of Tunisia in 1980 to that in 1984?
Your answer should be very brief. 0.67. What is the ratio of the Exports (in Local Currency Unit) of El Salvador in 1980 to that in 1985?
Offer a very short reply. 1.44. What is the ratio of the Exports (in Local Currency Unit) of Senegal in 1980 to that in 1985?
Provide a succinct answer. 0.48. What is the ratio of the Exports (in Local Currency Unit) of St. Vincent and the Grenadines in 1980 to that in 1985?
Offer a terse response. 0.4. What is the ratio of the Exports (in Local Currency Unit) of Tunisia in 1980 to that in 1985?
Keep it short and to the point. 0.63. What is the ratio of the Exports (in Local Currency Unit) of El Salvador in 1981 to that in 1982?
Offer a very short reply. 1.18. What is the ratio of the Exports (in Local Currency Unit) of Senegal in 1981 to that in 1982?
Offer a terse response. 0.92. What is the ratio of the Exports (in Local Currency Unit) of St. Vincent and the Grenadines in 1981 to that in 1982?
Offer a very short reply. 0.85. What is the ratio of the Exports (in Local Currency Unit) in Tunisia in 1981 to that in 1982?
Your answer should be compact. 0.97. What is the ratio of the Exports (in Local Currency Unit) in El Salvador in 1981 to that in 1983?
Offer a very short reply. 1.07. What is the ratio of the Exports (in Local Currency Unit) in Senegal in 1981 to that in 1983?
Your answer should be very brief. 0.74. What is the ratio of the Exports (in Local Currency Unit) in St. Vincent and the Grenadines in 1981 to that in 1983?
Make the answer very short. 0.74. What is the ratio of the Exports (in Local Currency Unit) in Tunisia in 1981 to that in 1983?
Offer a terse response. 0.88. What is the ratio of the Exports (in Local Currency Unit) in El Salvador in 1981 to that in 1984?
Provide a succinct answer. 1.15. What is the ratio of the Exports (in Local Currency Unit) in Senegal in 1981 to that in 1984?
Keep it short and to the point. 0.68. What is the ratio of the Exports (in Local Currency Unit) of St. Vincent and the Grenadines in 1981 to that in 1984?
Keep it short and to the point. 0.6. What is the ratio of the Exports (in Local Currency Unit) of Tunisia in 1981 to that in 1984?
Your answer should be compact. 0.81. What is the ratio of the Exports (in Local Currency Unit) in El Salvador in 1981 to that in 1985?
Keep it short and to the point. 1.08. What is the ratio of the Exports (in Local Currency Unit) in Senegal in 1981 to that in 1985?
Keep it short and to the point. 0.74. What is the ratio of the Exports (in Local Currency Unit) of St. Vincent and the Grenadines in 1981 to that in 1985?
Your answer should be compact. 0.52. What is the ratio of the Exports (in Local Currency Unit) in Tunisia in 1981 to that in 1985?
Give a very brief answer. 0.76. What is the ratio of the Exports (in Local Currency Unit) in El Salvador in 1982 to that in 1983?
Keep it short and to the point. 0.9. What is the ratio of the Exports (in Local Currency Unit) in Senegal in 1982 to that in 1983?
Keep it short and to the point. 0.8. What is the ratio of the Exports (in Local Currency Unit) in St. Vincent and the Grenadines in 1982 to that in 1983?
Make the answer very short. 0.87. What is the ratio of the Exports (in Local Currency Unit) of Tunisia in 1982 to that in 1983?
Keep it short and to the point. 0.91. What is the ratio of the Exports (in Local Currency Unit) of Senegal in 1982 to that in 1984?
Your answer should be very brief. 0.74. What is the ratio of the Exports (in Local Currency Unit) in St. Vincent and the Grenadines in 1982 to that in 1984?
Make the answer very short. 0.7. What is the ratio of the Exports (in Local Currency Unit) in Tunisia in 1982 to that in 1984?
Your answer should be compact. 0.84. What is the ratio of the Exports (in Local Currency Unit) of El Salvador in 1982 to that in 1985?
Offer a terse response. 0.91. What is the ratio of the Exports (in Local Currency Unit) in Senegal in 1982 to that in 1985?
Make the answer very short. 0.81. What is the ratio of the Exports (in Local Currency Unit) in St. Vincent and the Grenadines in 1982 to that in 1985?
Your response must be concise. 0.61. What is the ratio of the Exports (in Local Currency Unit) of Tunisia in 1982 to that in 1985?
Provide a short and direct response. 0.79. What is the ratio of the Exports (in Local Currency Unit) of El Salvador in 1983 to that in 1984?
Your answer should be compact. 1.08. What is the ratio of the Exports (in Local Currency Unit) in Senegal in 1983 to that in 1984?
Keep it short and to the point. 0.93. What is the ratio of the Exports (in Local Currency Unit) in St. Vincent and the Grenadines in 1983 to that in 1984?
Provide a short and direct response. 0.81. What is the ratio of the Exports (in Local Currency Unit) in Tunisia in 1983 to that in 1984?
Offer a terse response. 0.92. What is the ratio of the Exports (in Local Currency Unit) in El Salvador in 1983 to that in 1985?
Offer a terse response. 1.01. What is the ratio of the Exports (in Local Currency Unit) of Senegal in 1983 to that in 1985?
Give a very brief answer. 1. What is the ratio of the Exports (in Local Currency Unit) of St. Vincent and the Grenadines in 1983 to that in 1985?
Provide a succinct answer. 0.7. What is the ratio of the Exports (in Local Currency Unit) in Tunisia in 1983 to that in 1985?
Provide a succinct answer. 0.86. What is the ratio of the Exports (in Local Currency Unit) in El Salvador in 1984 to that in 1985?
Your response must be concise. 0.94. What is the ratio of the Exports (in Local Currency Unit) of Senegal in 1984 to that in 1985?
Offer a terse response. 1.08. What is the ratio of the Exports (in Local Currency Unit) of St. Vincent and the Grenadines in 1984 to that in 1985?
Offer a very short reply. 0.87. What is the ratio of the Exports (in Local Currency Unit) of Tunisia in 1984 to that in 1985?
Your response must be concise. 0.94. What is the difference between the highest and the second highest Exports (in Local Currency Unit) of El Salvador?
Your answer should be compact. 5.96e+07. What is the difference between the highest and the second highest Exports (in Local Currency Unit) in Senegal?
Your answer should be very brief. 2.98e+1. What is the difference between the highest and the second highest Exports (in Local Currency Unit) in St. Vincent and the Grenadines?
Offer a very short reply. 2.95e+07. What is the difference between the highest and the second highest Exports (in Local Currency Unit) of Tunisia?
Keep it short and to the point. 1.39e+08. What is the difference between the highest and the lowest Exports (in Local Currency Unit) of El Salvador?
Ensure brevity in your answer.  5.06e+08. What is the difference between the highest and the lowest Exports (in Local Currency Unit) of Senegal?
Offer a very short reply. 2.25e+11. What is the difference between the highest and the lowest Exports (in Local Currency Unit) in St. Vincent and the Grenadines?
Provide a succinct answer. 1.46e+08. What is the difference between the highest and the lowest Exports (in Local Currency Unit) of Tunisia?
Give a very brief answer. 1.11e+09. 